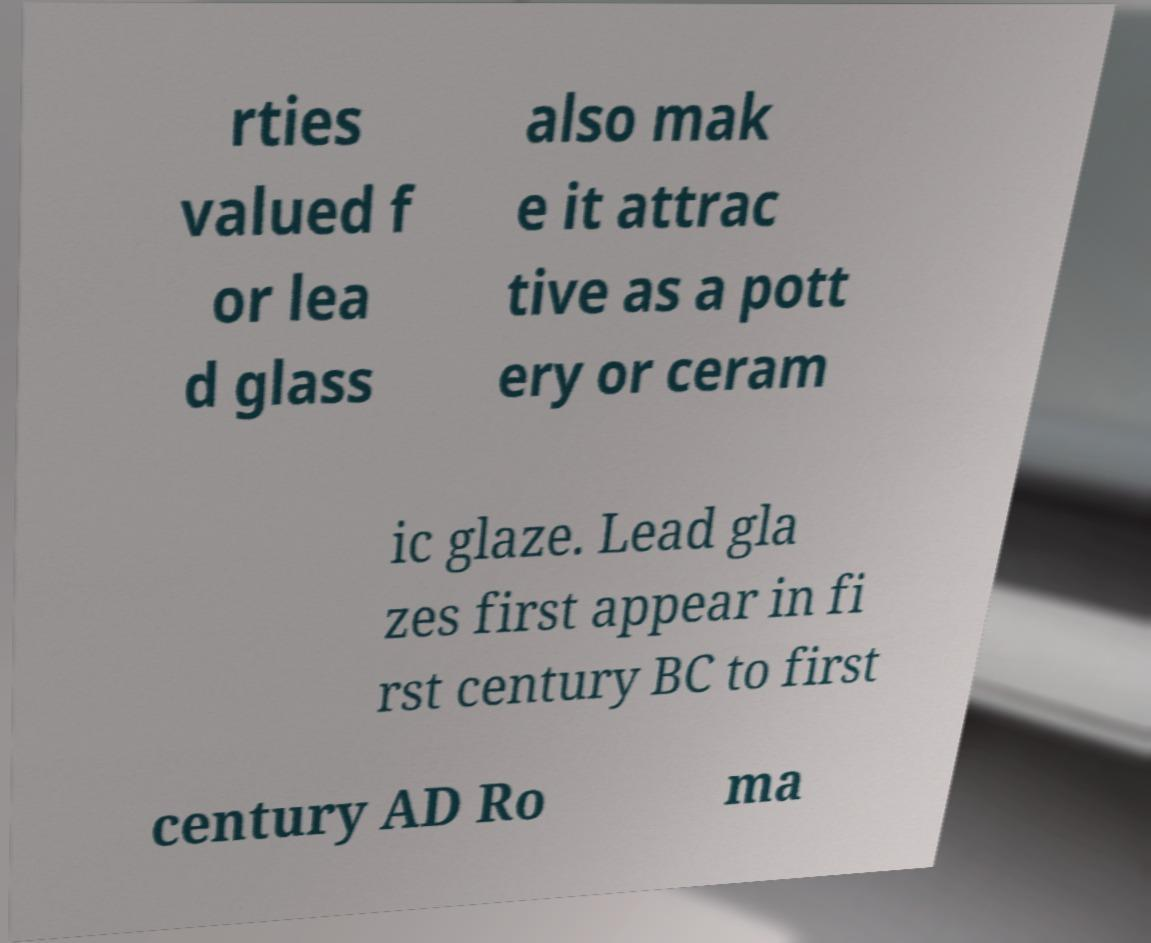Can you accurately transcribe the text from the provided image for me? rties valued f or lea d glass also mak e it attrac tive as a pott ery or ceram ic glaze. Lead gla zes first appear in fi rst century BC to first century AD Ro ma 